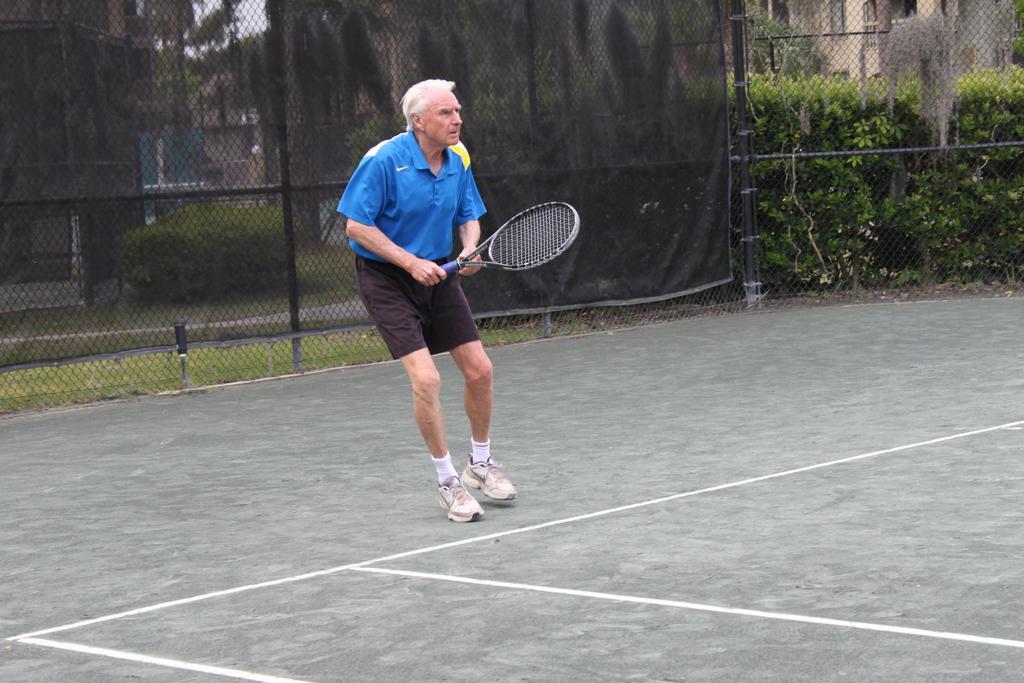Please provide a concise description of this image. In this image i can see a man playing holding a bat at the background i can see a railing , tree and a building 